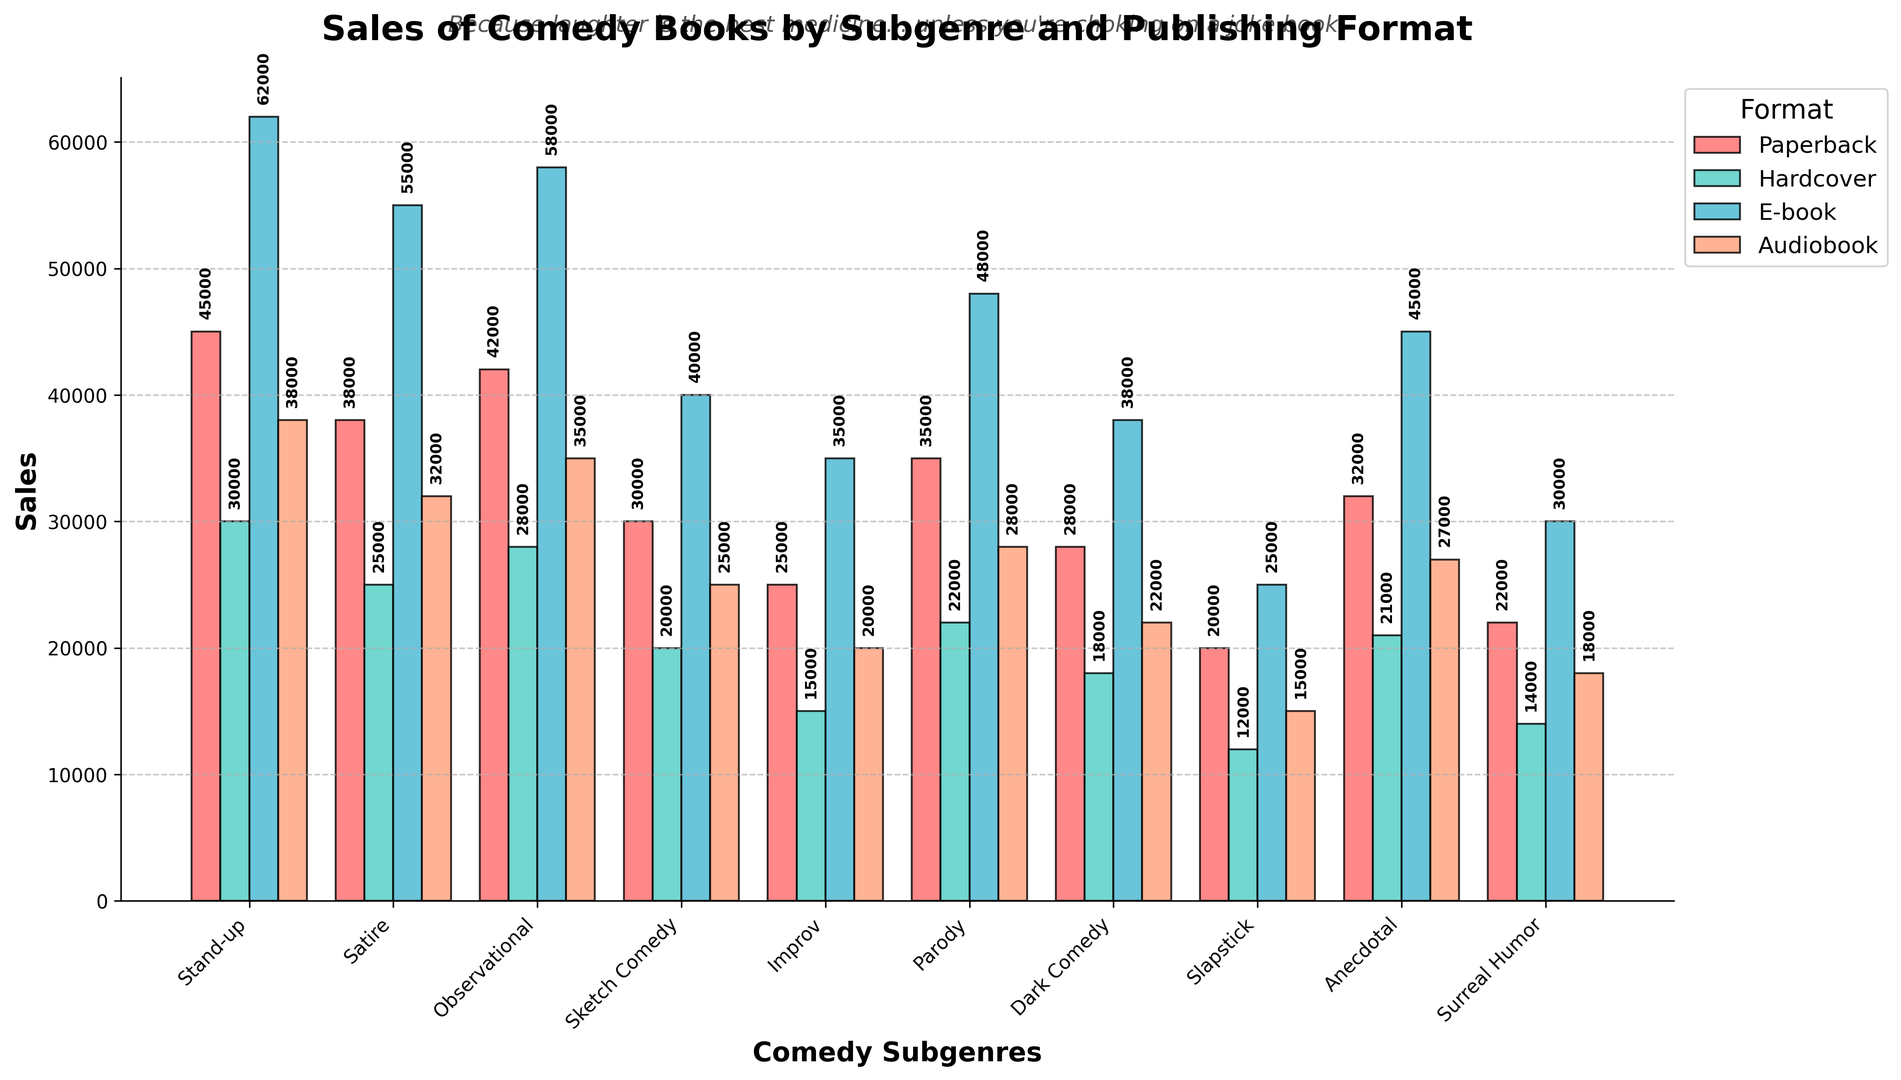what is the total sales for 'Stand-up' books across all formats? First, look at the sales values for 'Stand-up' in all formats: Paperback (45000), Hardcover (30000), E-book (62000), and Audiobook (38000). Sum these values to get the total sales: 45000 + 30000 + 62000 + 38000 = 175000
Answer: 175000 Which subgenre has the highest sales in the E-book format? Observe the heights of the bars for the E-book format. 'Stand-up' has the highest bar with a value of 62000, which is the maximum value among all subgenres in the E-book category
Answer: Stand-up Compare 'Sketch Comedy’ sales between Paperback and Audiobook formats. Which format has higher sales? Look at the 'Sketch Comedy' bars for both Paperback (30000) and Audiobook (25000). Since 30000 (Paperback) is greater than 25000 (Audiobook), the Paperback format has higher sales
Answer: Paperback Which subgenre has the lowest sales in the Hardcover format? Among all the heights of bars for the Hardcover format, 'Slapstick' has the shortest bar, indicating the lowest sales with a value of 12000
Answer: Slapstick How do the total sales for 'Observational' books compare to 'Satire' books across all formats? Calculate the total sales for 'Observational': Paperback (42000) + Hardcover (28000) + E-book (58000) + Audiobook (35000) = 163000 and for 'Satire': Paperback (38000) + Hardcover (25000) + E-book (55000) + Audiobook (32000) = 150000. Since 163000 (Observational) > 150000 (Satire), 'Observational' has higher total sales
Answer: Observational Which format consistently has the highest sales across all subgenres? Observe the different colored bars and note their heights throughout the subgenres. The E-book format consistently shows the tallest bars in most subgenres, indicating the highest sales
Answer: E-book What’s the difference in sales between 'Improv' and 'Dark Comedy' in the Paperback format? Look at the sales for 'Improv' in Paperback (25000) and 'Dark Comedy' in Paperback (28000). Subtract the smaller value from the larger value: 28000 - 25000 = 3000
Answer: 3000 What is the average sales for ‘Parody’ books across Paperback and Audiobook formats? Add the sales values for 'Parody' books in Paperback (35000) and Audiobook (28000) and divide by 2: (35000 + 28000) / 2 = 31500
Answer: 31500 Which two subgenres have the most similar sales figures in the Audiobook format? By comparing the bars within the Audiobook format, the sales figures for 'Parody' (28000) and 'Anecdotal' (27000) are closest, with a difference of only 1000
Answer: Parody and Anecdotal 